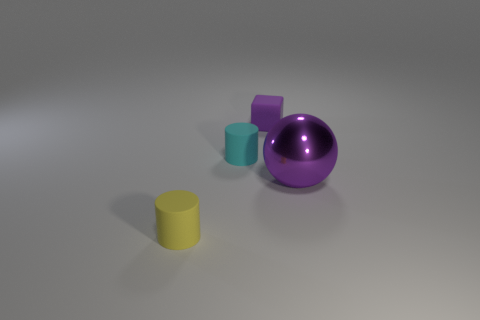Is there anything else that is the same size as the sphere?
Ensure brevity in your answer.  No. Is there anything else that has the same material as the sphere?
Offer a terse response. No. There is a cylinder that is to the right of the tiny cylinder that is in front of the cyan matte cylinder; what is its material?
Your answer should be compact. Rubber. What number of rubber objects have the same color as the big metal ball?
Give a very brief answer. 1. What shape is the small yellow object that is made of the same material as the small cyan thing?
Your answer should be compact. Cylinder. There is a thing that is in front of the big purple metallic object; how big is it?
Ensure brevity in your answer.  Small. Are there the same number of spheres that are in front of the large ball and shiny things that are to the left of the small yellow rubber thing?
Your answer should be compact. Yes. What is the color of the object that is on the right side of the matte object that is behind the rubber cylinder that is behind the big purple shiny ball?
Provide a succinct answer. Purple. How many small matte cylinders are behind the small yellow cylinder and in front of the small cyan cylinder?
Give a very brief answer. 0. Does the small object in front of the big purple ball have the same color as the tiny matte thing to the right of the cyan matte cylinder?
Your answer should be very brief. No. 